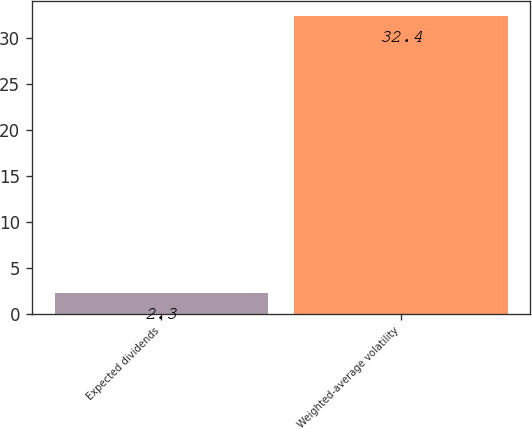<chart> <loc_0><loc_0><loc_500><loc_500><bar_chart><fcel>Expected dividends<fcel>Weighted-average volatility<nl><fcel>2.3<fcel>32.4<nl></chart> 